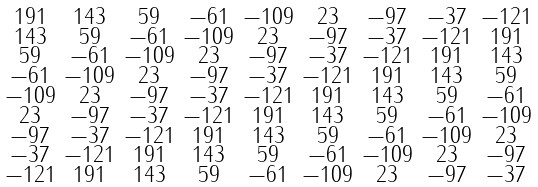<formula> <loc_0><loc_0><loc_500><loc_500>\begin{smallmatrix} 1 9 1 & 1 4 3 & 5 9 & - 6 1 & - 1 0 9 & 2 3 & - 9 7 & - 3 7 & - 1 2 1 \\ 1 4 3 & 5 9 & - 6 1 & - 1 0 9 & 2 3 & - 9 7 & - 3 7 & - 1 2 1 & 1 9 1 \\ 5 9 & - 6 1 & - 1 0 9 & 2 3 & - 9 7 & - 3 7 & - 1 2 1 & 1 9 1 & 1 4 3 \\ - 6 1 & - 1 0 9 & 2 3 & - 9 7 & - 3 7 & - 1 2 1 & 1 9 1 & 1 4 3 & 5 9 \\ - 1 0 9 & 2 3 & - 9 7 & - 3 7 & - 1 2 1 & 1 9 1 & 1 4 3 & 5 9 & - 6 1 \\ 2 3 & - 9 7 & - 3 7 & - 1 2 1 & 1 9 1 & 1 4 3 & 5 9 & - 6 1 & - 1 0 9 \\ - 9 7 & - 3 7 & - 1 2 1 & 1 9 1 & 1 4 3 & 5 9 & - 6 1 & - 1 0 9 & 2 3 \\ - 3 7 & - 1 2 1 & 1 9 1 & 1 4 3 & 5 9 & - 6 1 & - 1 0 9 & 2 3 & - 9 7 \\ - 1 2 1 & 1 9 1 & 1 4 3 & 5 9 & - 6 1 & - 1 0 9 & 2 3 & - 9 7 & - 3 7 \end{smallmatrix}</formula> 